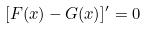<formula> <loc_0><loc_0><loc_500><loc_500>[ F ( x ) - G ( x ) ] ^ { \prime } = 0</formula> 